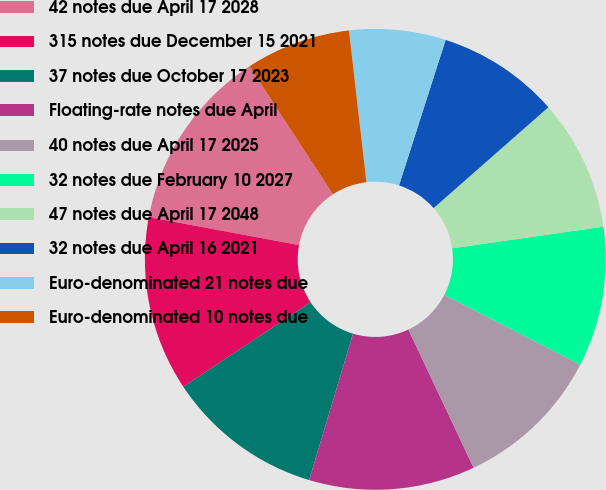<chart> <loc_0><loc_0><loc_500><loc_500><pie_chart><fcel>42 notes due April 17 2028<fcel>315 notes due December 15 2021<fcel>37 notes due October 17 2023<fcel>Floating-rate notes due April<fcel>40 notes due April 17 2025<fcel>32 notes due February 10 2027<fcel>47 notes due April 17 2048<fcel>32 notes due April 16 2021<fcel>Euro-denominated 21 notes due<fcel>Euro-denominated 10 notes due<nl><fcel>12.87%<fcel>12.26%<fcel>11.04%<fcel>11.65%<fcel>10.43%<fcel>9.82%<fcel>9.21%<fcel>8.59%<fcel>6.76%<fcel>7.37%<nl></chart> 